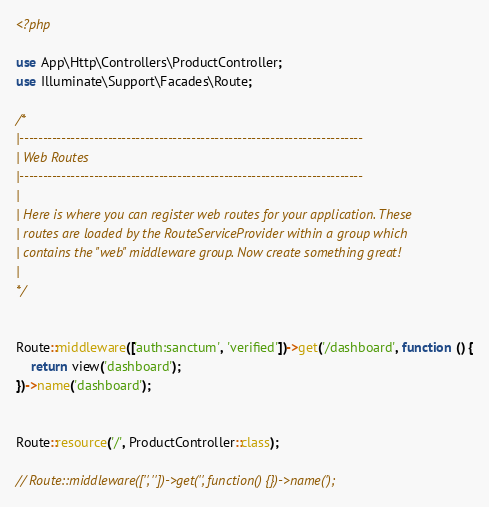<code> <loc_0><loc_0><loc_500><loc_500><_PHP_><?php

use App\Http\Controllers\ProductController;
use Illuminate\Support\Facades\Route;

/*
|--------------------------------------------------------------------------
| Web Routes
|--------------------------------------------------------------------------
|
| Here is where you can register web routes for your application. These
| routes are loaded by the RouteServiceProvider within a group which
| contains the "web" middleware group. Now create something great!
|
*/


Route::middleware(['auth:sanctum', 'verified'])->get('/dashboard', function () {
    return view('dashboard');
})->name('dashboard');


Route::resource('/', ProductController::class);

// Route::middleware(['', ''])->get('', function() {})->name(');
</code> 